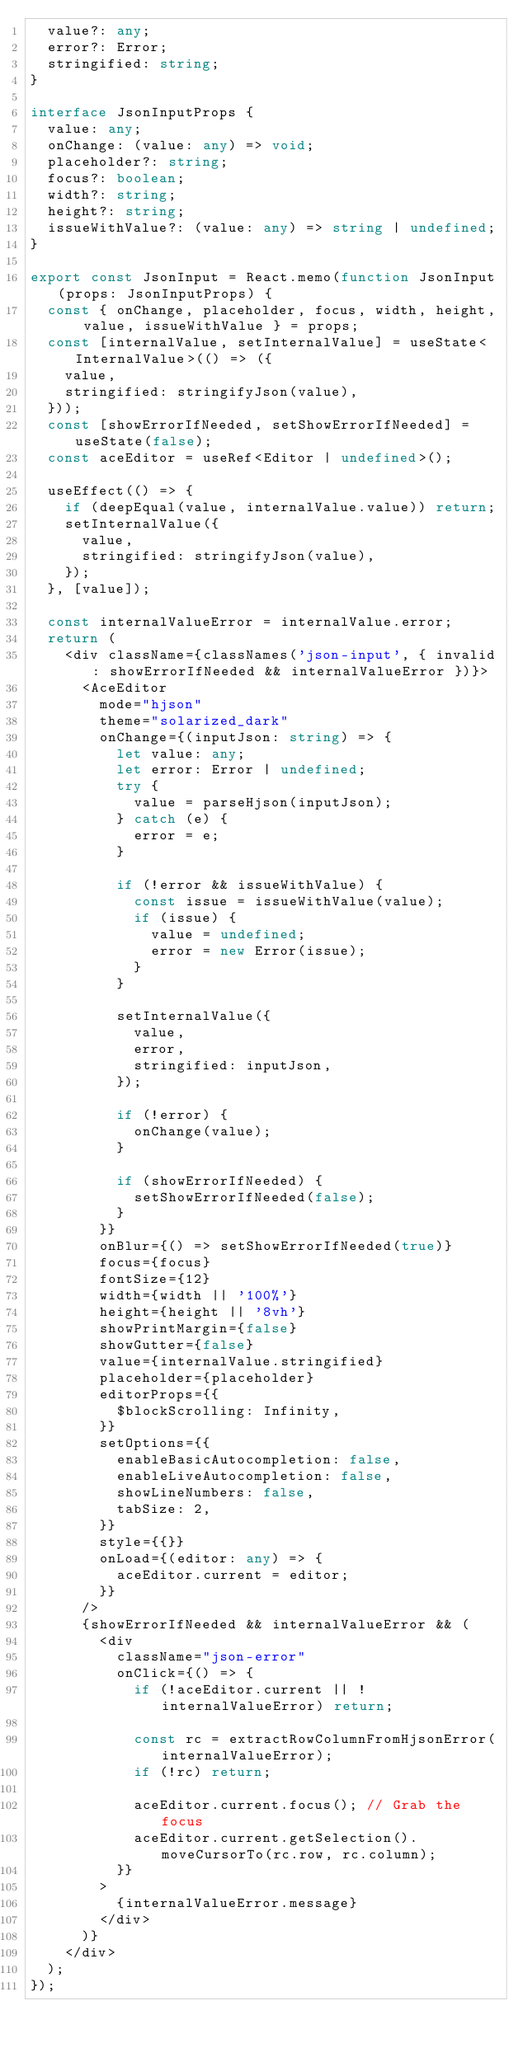<code> <loc_0><loc_0><loc_500><loc_500><_TypeScript_>  value?: any;
  error?: Error;
  stringified: string;
}

interface JsonInputProps {
  value: any;
  onChange: (value: any) => void;
  placeholder?: string;
  focus?: boolean;
  width?: string;
  height?: string;
  issueWithValue?: (value: any) => string | undefined;
}

export const JsonInput = React.memo(function JsonInput(props: JsonInputProps) {
  const { onChange, placeholder, focus, width, height, value, issueWithValue } = props;
  const [internalValue, setInternalValue] = useState<InternalValue>(() => ({
    value,
    stringified: stringifyJson(value),
  }));
  const [showErrorIfNeeded, setShowErrorIfNeeded] = useState(false);
  const aceEditor = useRef<Editor | undefined>();

  useEffect(() => {
    if (deepEqual(value, internalValue.value)) return;
    setInternalValue({
      value,
      stringified: stringifyJson(value),
    });
  }, [value]);

  const internalValueError = internalValue.error;
  return (
    <div className={classNames('json-input', { invalid: showErrorIfNeeded && internalValueError })}>
      <AceEditor
        mode="hjson"
        theme="solarized_dark"
        onChange={(inputJson: string) => {
          let value: any;
          let error: Error | undefined;
          try {
            value = parseHjson(inputJson);
          } catch (e) {
            error = e;
          }

          if (!error && issueWithValue) {
            const issue = issueWithValue(value);
            if (issue) {
              value = undefined;
              error = new Error(issue);
            }
          }

          setInternalValue({
            value,
            error,
            stringified: inputJson,
          });

          if (!error) {
            onChange(value);
          }

          if (showErrorIfNeeded) {
            setShowErrorIfNeeded(false);
          }
        }}
        onBlur={() => setShowErrorIfNeeded(true)}
        focus={focus}
        fontSize={12}
        width={width || '100%'}
        height={height || '8vh'}
        showPrintMargin={false}
        showGutter={false}
        value={internalValue.stringified}
        placeholder={placeholder}
        editorProps={{
          $blockScrolling: Infinity,
        }}
        setOptions={{
          enableBasicAutocompletion: false,
          enableLiveAutocompletion: false,
          showLineNumbers: false,
          tabSize: 2,
        }}
        style={{}}
        onLoad={(editor: any) => {
          aceEditor.current = editor;
        }}
      />
      {showErrorIfNeeded && internalValueError && (
        <div
          className="json-error"
          onClick={() => {
            if (!aceEditor.current || !internalValueError) return;

            const rc = extractRowColumnFromHjsonError(internalValueError);
            if (!rc) return;

            aceEditor.current.focus(); // Grab the focus
            aceEditor.current.getSelection().moveCursorTo(rc.row, rc.column);
          }}
        >
          {internalValueError.message}
        </div>
      )}
    </div>
  );
});
</code> 